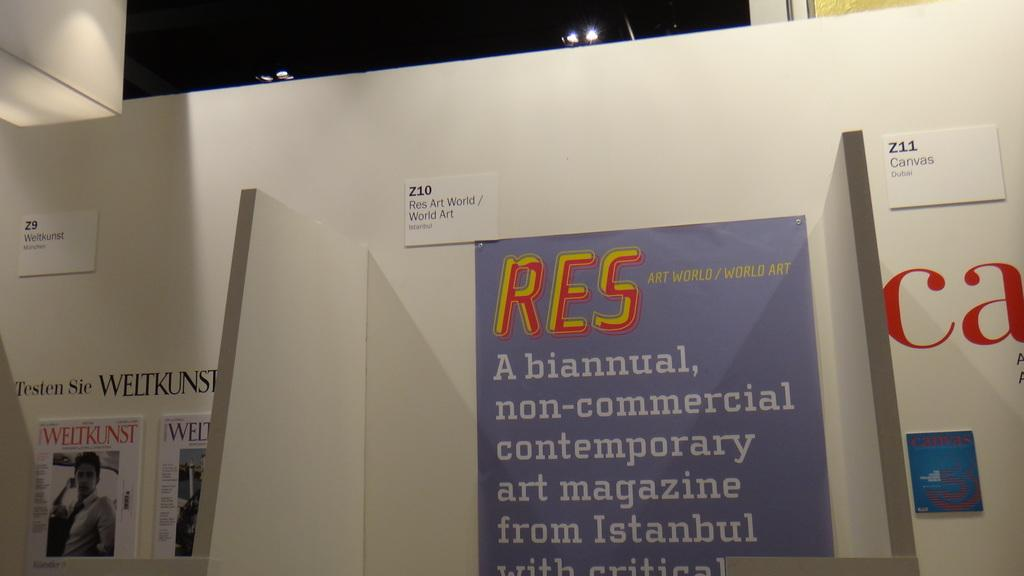What is on the paper that is visible in the image? There is writing on the paper in the image. What is the paper attached to? The paper is attached to a white object. What type of flag is visible in the image? There is no flag present in the image; it only features a paper with writing on it and a white object. 